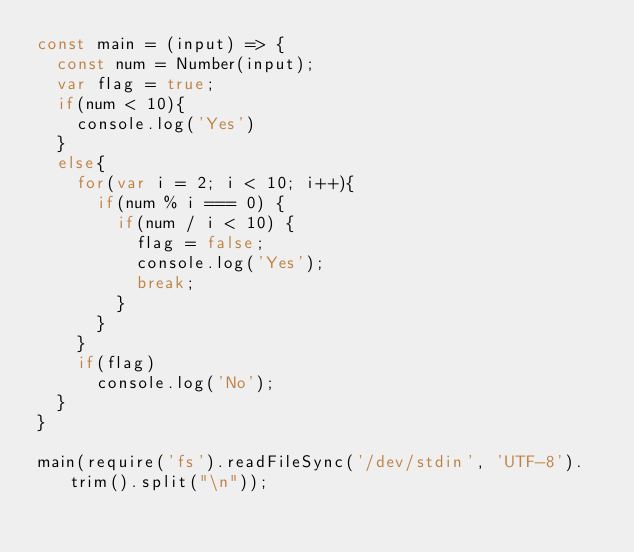<code> <loc_0><loc_0><loc_500><loc_500><_JavaScript_>const main = (input) => {
  const num = Number(input);
  var flag = true;
  if(num < 10){
    console.log('Yes')
  }
  else{
    for(var i = 2; i < 10; i++){
      if(num % i === 0) {
        if(num / i < 10) {
          flag = false;
          console.log('Yes');
          break;
        }
      }
    }
    if(flag)
      console.log('No');
  }
}

main(require('fs').readFileSync('/dev/stdin', 'UTF-8').trim().split("\n"));</code> 